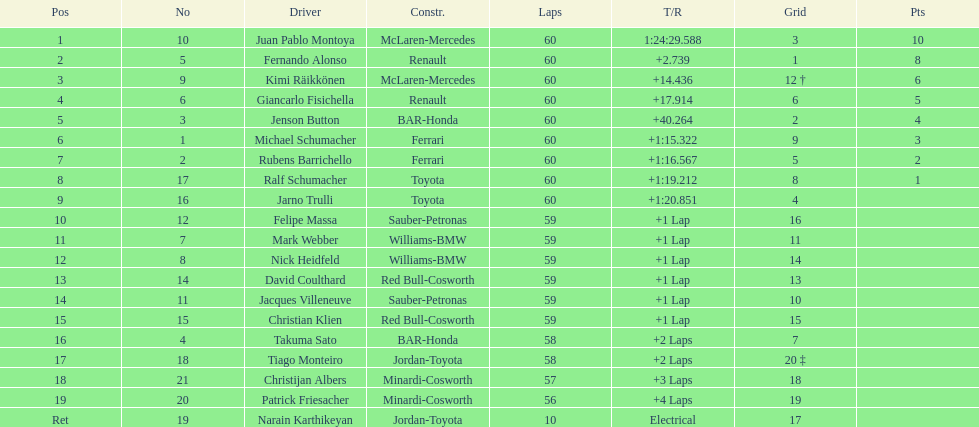Which driver in the top 8, drives a mclaran-mercedes but is not in first place? Kimi Räikkönen. 